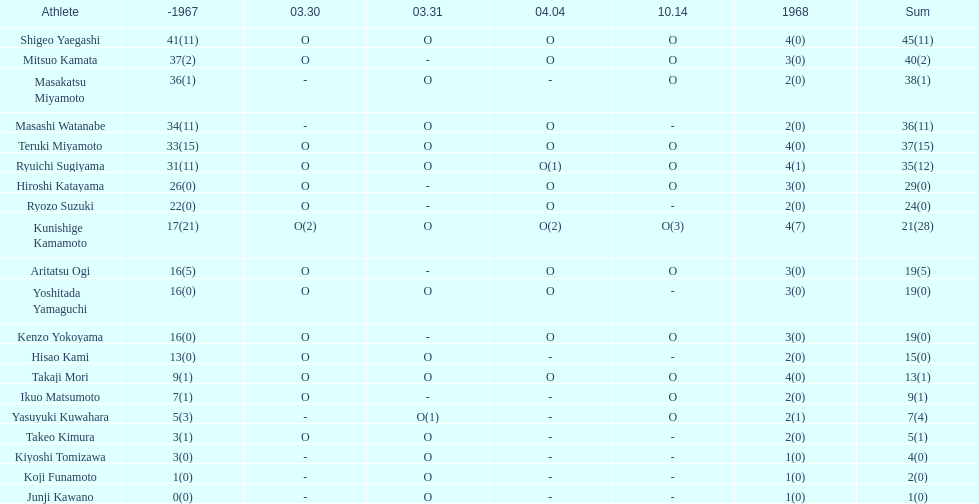Total appearances by masakatsu miyamoto? 38. 